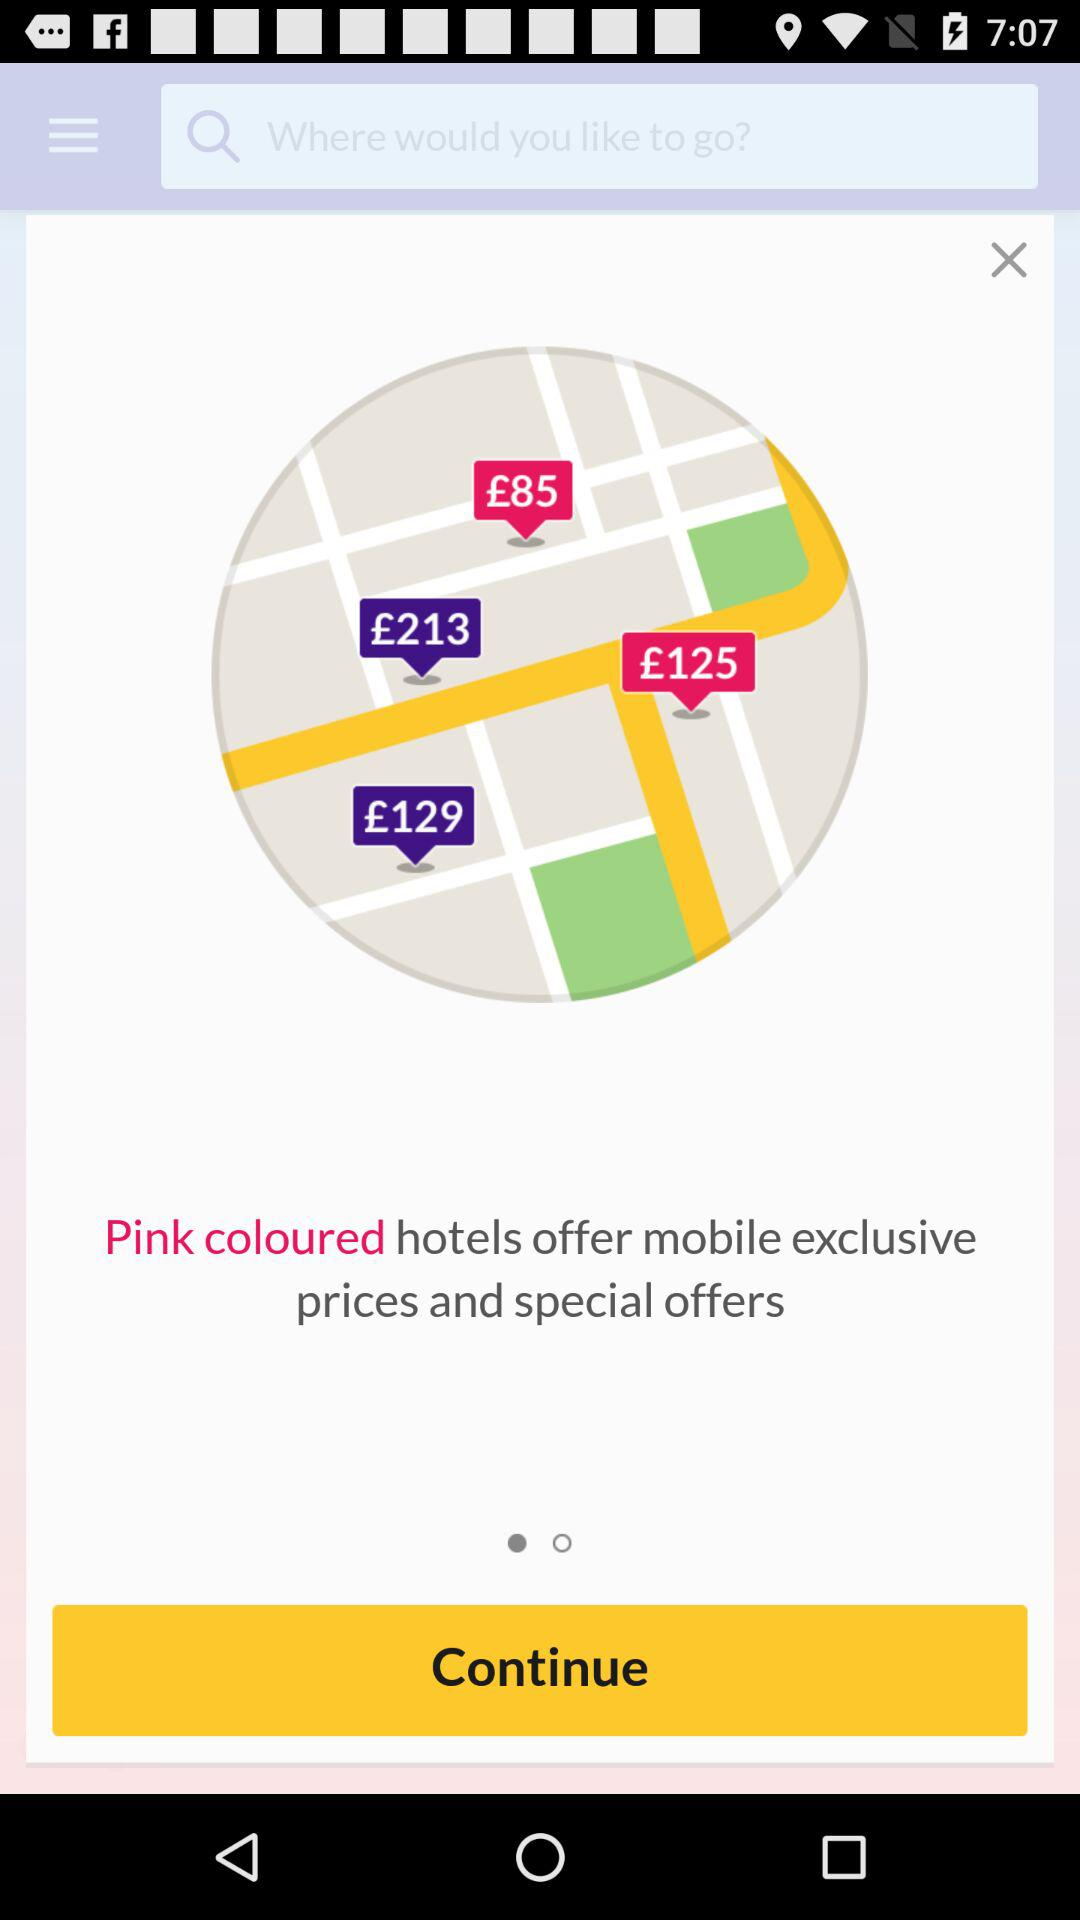What color hotels offer mobile exclusive prices and special offers? The pink colored hotels. 